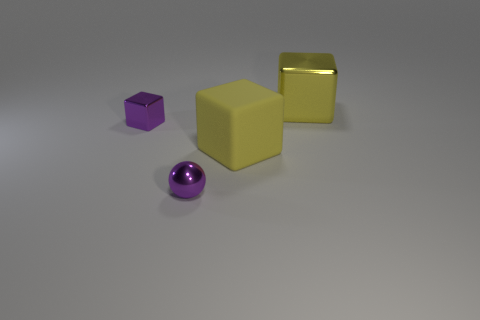Add 4 big cyan metallic blocks. How many objects exist? 8 Subtract all balls. How many objects are left? 3 Add 2 big yellow things. How many big yellow things are left? 4 Add 1 yellow objects. How many yellow objects exist? 3 Subtract 0 red blocks. How many objects are left? 4 Subtract all gray rubber spheres. Subtract all yellow metallic objects. How many objects are left? 3 